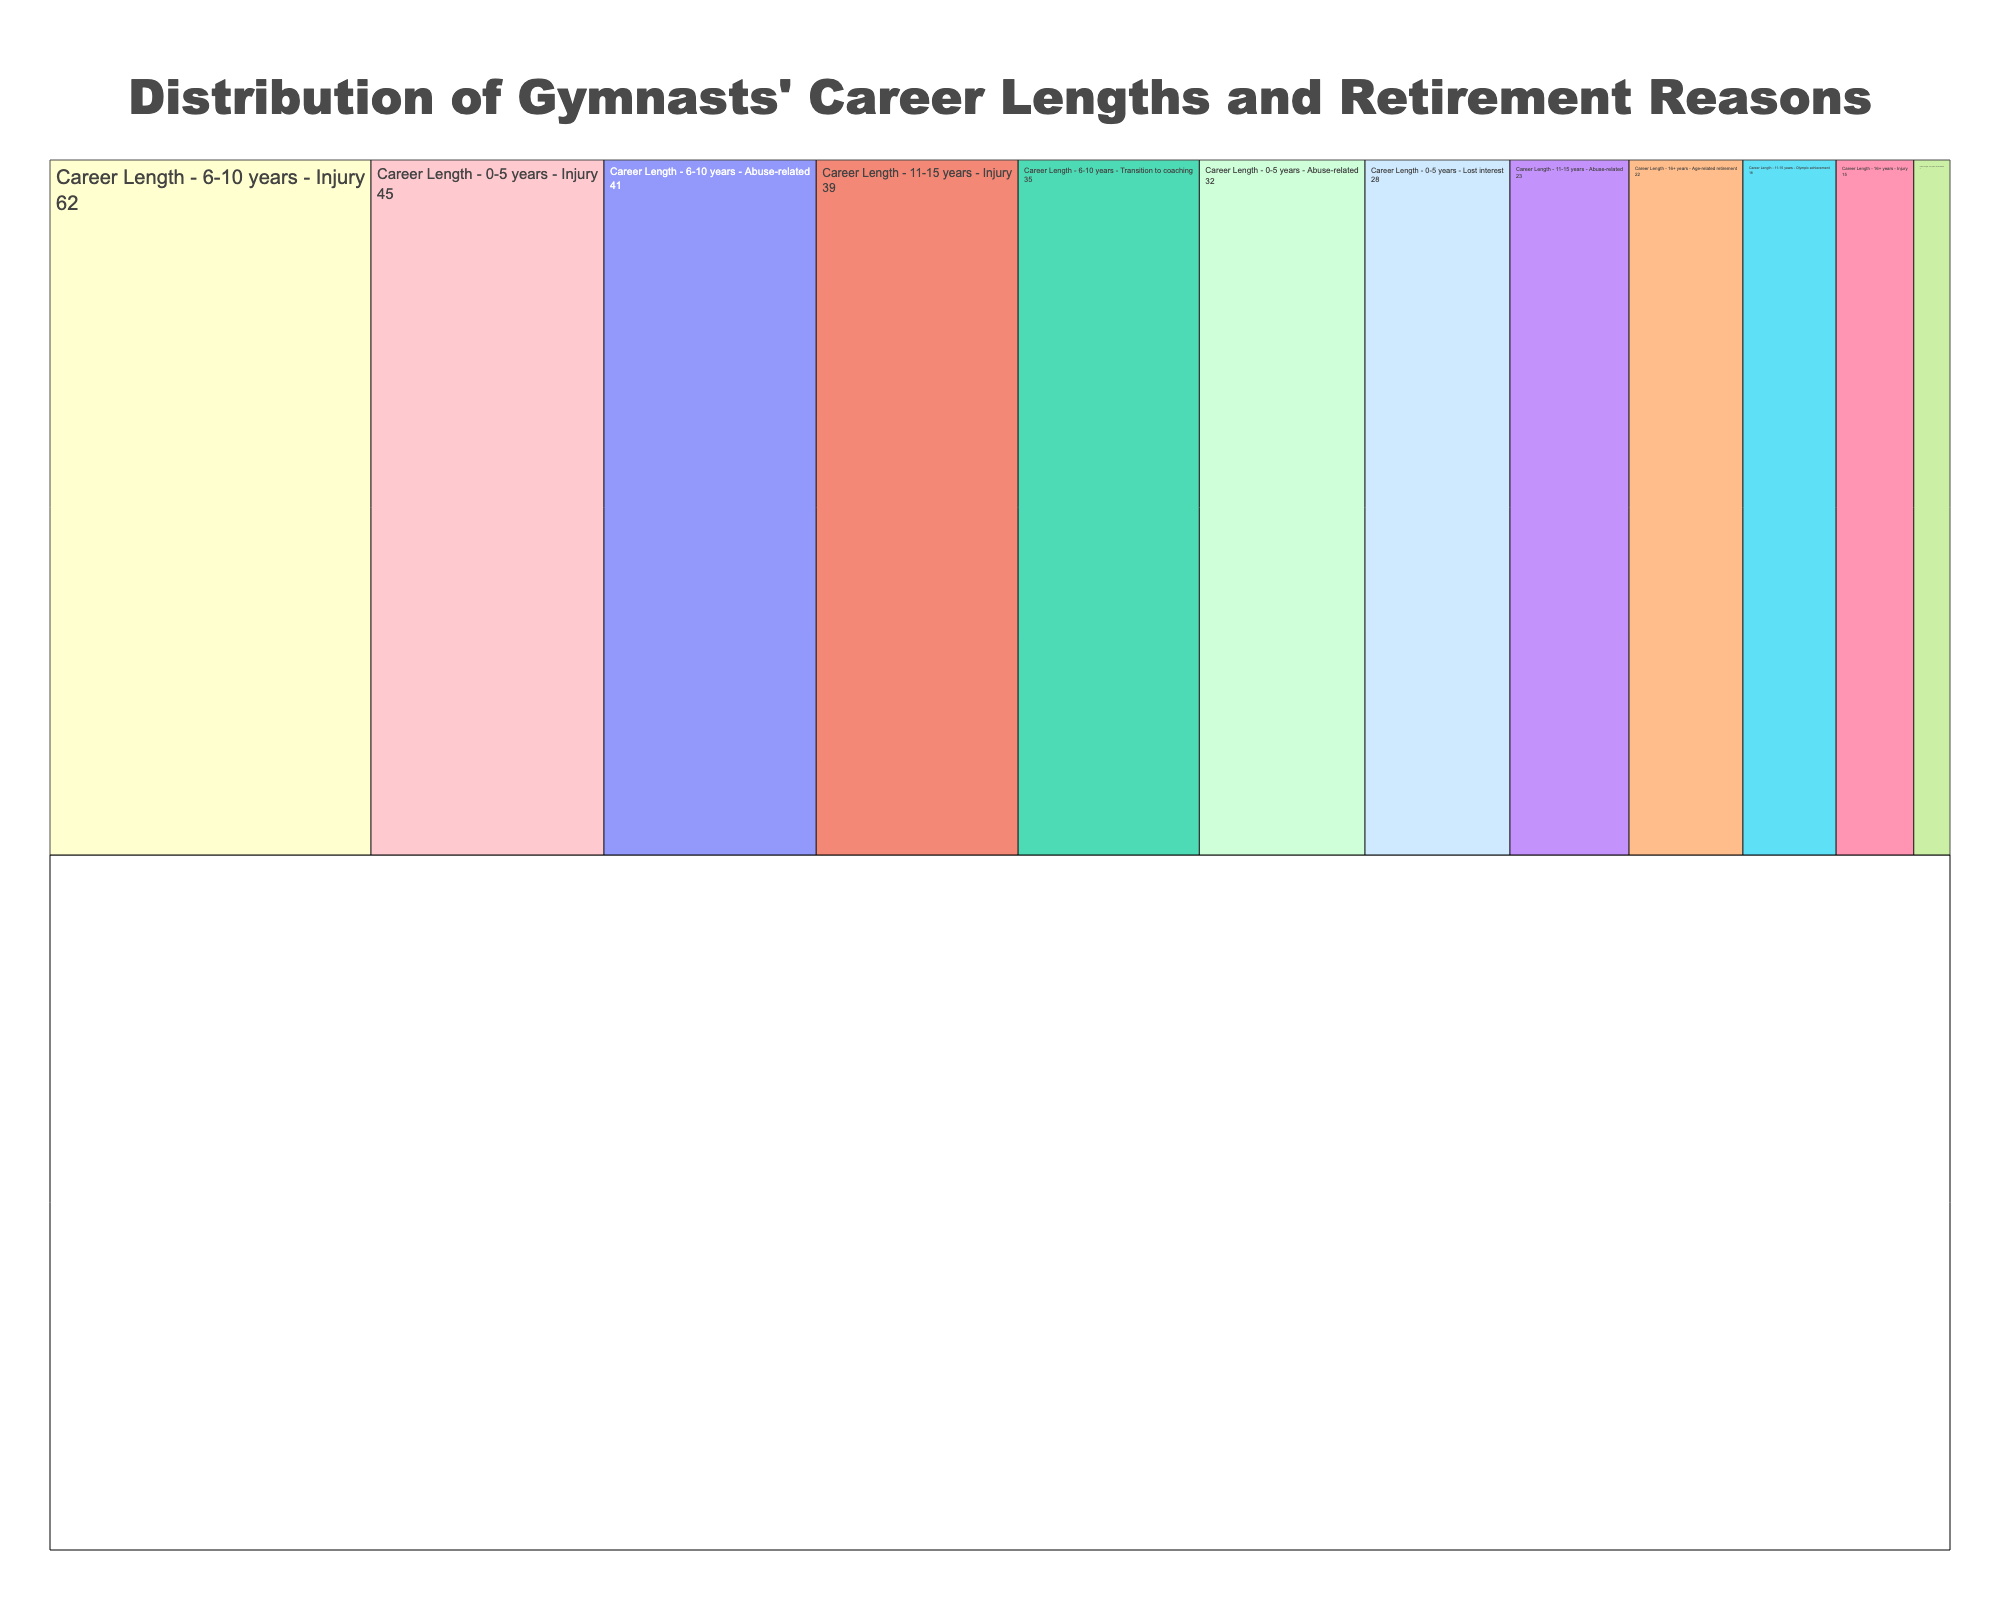What is the most common reason for retirement within 0-5 years? The most common reason for retirement within 0-5 years can be found by identifying the largest value in this segment. Injury has a count of 45, which is the highest among the reasons within this segment.
Answer: Injury What is the total number of gymnasts who retired due to abuse-related factors? To find the total number of gymnasts who retired due to abuse-related factors, sum up the counts across all career lengths (32 for 0-5 years, 41 for 6-10 years, 23 for 11-15 years, and 7 for 16+ years). The sum is 32 + 41 + 23 + 7 = 103.
Answer: 103 Which career length segment has the highest number of gymnasts who retired due to injury? To determine this, compare the injury-related counts across all career length segments. The counts are 45 (0-5 years), 62 (6-10 years), 39 (11-15 years), and 15 (16+ years). The highest count is 62 within the 6-10 years segment.
Answer: 6-10 years What is the least common reason for retirement within the 16+ years segment? The least common reason within the 16+ years segment can be found by identifying the smallest count. Abuse-related factors have a count of 7, the lowest in this segment.
Answer: Abuse-related How many gymnasts retired after 6-10 years due to non-abuse-related reasons? To find this, sum the counts for injury and transition to coaching within the 6-10 years segment (62 for injury and 35 for transition to coaching). The calculation is 62 + 35 = 97.
Answer: 97 Compare the number of gymnasts who retired due to lost interest within 0-5 years and age-related retirement within 16+ years. Compare the counts directly: 28 gymnasts retired due to lost interest within 0-5 years, and 22 retired due to age-related reasons within 16+ years. Since 28 is greater than 22, more gymnasts retired due to lost interest.
Answer: Lost interest (0-5 years) What is the sum of all gymnasts who retired across all reasons within the 11-15 years segment? Add the counts for injury, abuse-related, and Olympic achievement within the 11-15 years segment (39 + 23 + 18). The sum is 39 + 23 + 18 = 80.
Answer: 80 What percentage of gymnasts who had careers of 16+ years retired due to injury? There are 15 gymnasts who retired due to injury out of a total of 44 in the 16+ years segment (15 for injury, 7 for abuse-related, and 22 for age-related). The percentage is (15/44) * 100 ≈ 34.09%.
Answer: 34.09% How does the number of gymnasts who retired after achieving an Olympic achievement compare to those who retired due to a transition to coaching? Compare the counts directly: 18 retired after Olympic achievement (11-15 years), and 35 retired due to transition to coaching (6-10 years). Since 35 is greater than 18, more gymnasts retired due to transition to coaching.
Answer: Transition to coaching (35) What is the overall percentage of gymnasts who retired because of injury out of all retired gymnasts? Summing the counts for injuries across all segments (45 + 62 + 39 + 15 = 161) and the total number of retired gymnasts (total of all counts: 45 + 32 + 28 + 62 + 41 + 35 + 39 + 23 + 18 + 15 + 7 + 22 = 367). The percentage is (161/367) * 100 ≈ 43.86%.
Answer: 43.86% 